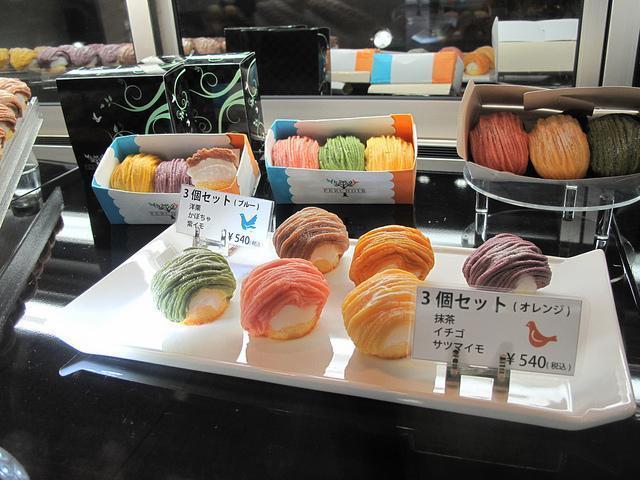How many pink donuts are there?
Give a very brief answer. 3. How many cakes can you see?
Give a very brief answer. 9. How many airplanes are in this picture?
Give a very brief answer. 0. 